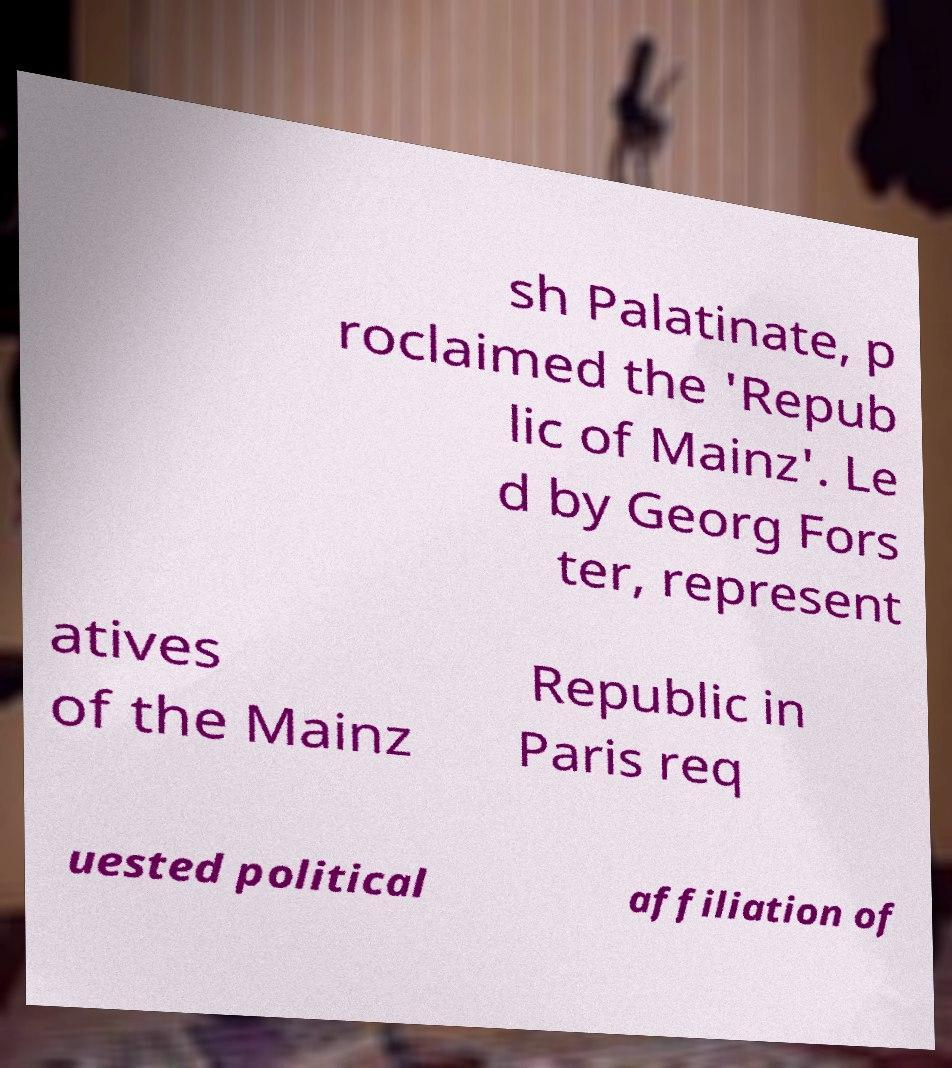Could you extract and type out the text from this image? sh Palatinate, p roclaimed the 'Repub lic of Mainz'. Le d by Georg Fors ter, represent atives of the Mainz Republic in Paris req uested political affiliation of 